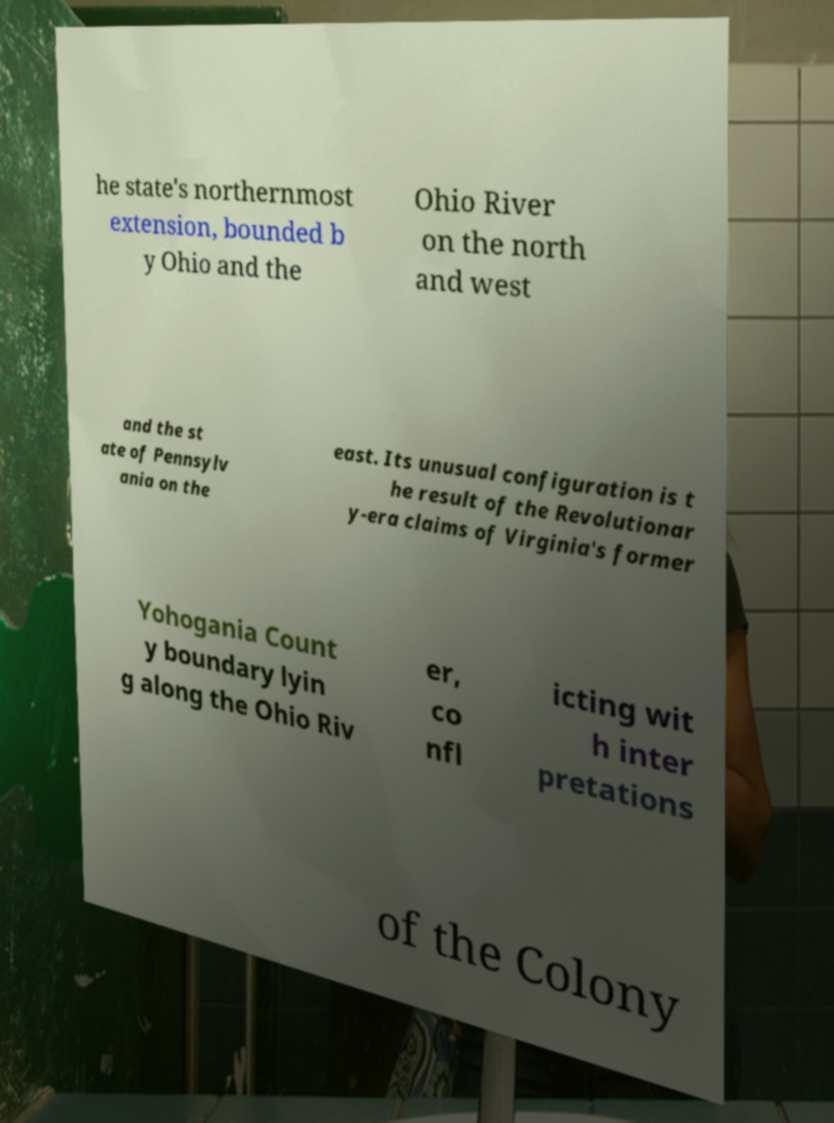What messages or text are displayed in this image? I need them in a readable, typed format. he state's northernmost extension, bounded b y Ohio and the Ohio River on the north and west and the st ate of Pennsylv ania on the east. Its unusual configuration is t he result of the Revolutionar y-era claims of Virginia's former Yohogania Count y boundary lyin g along the Ohio Riv er, co nfl icting wit h inter pretations of the Colony 